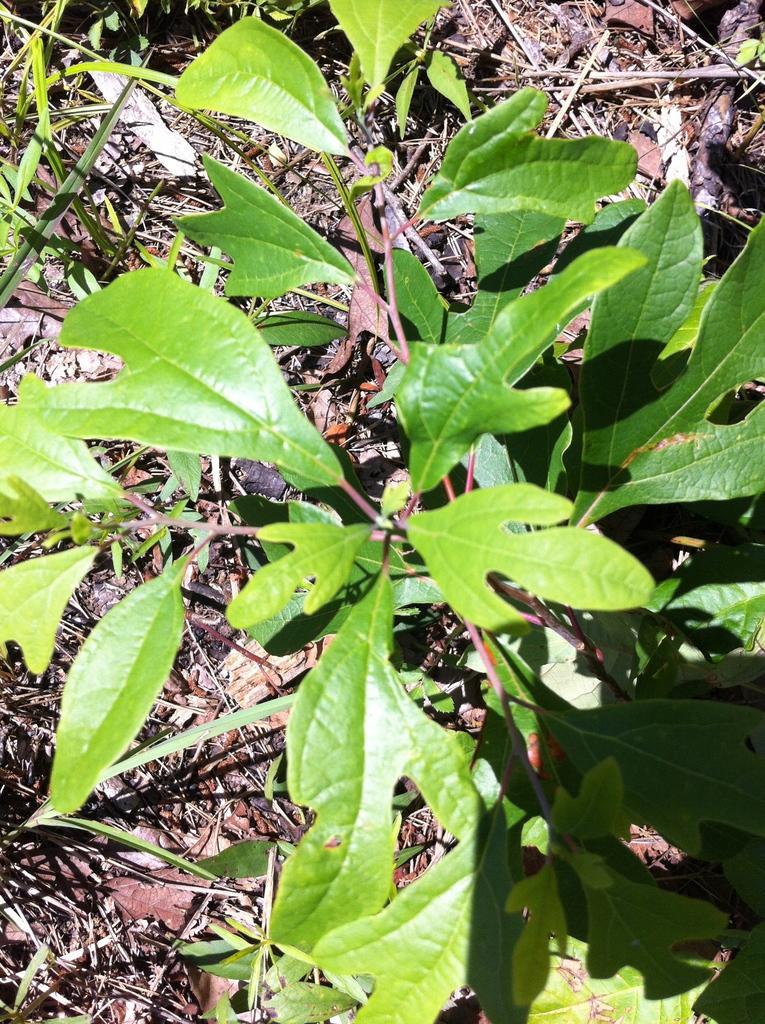Can you describe this image briefly? In the center of the image we can see plants. 